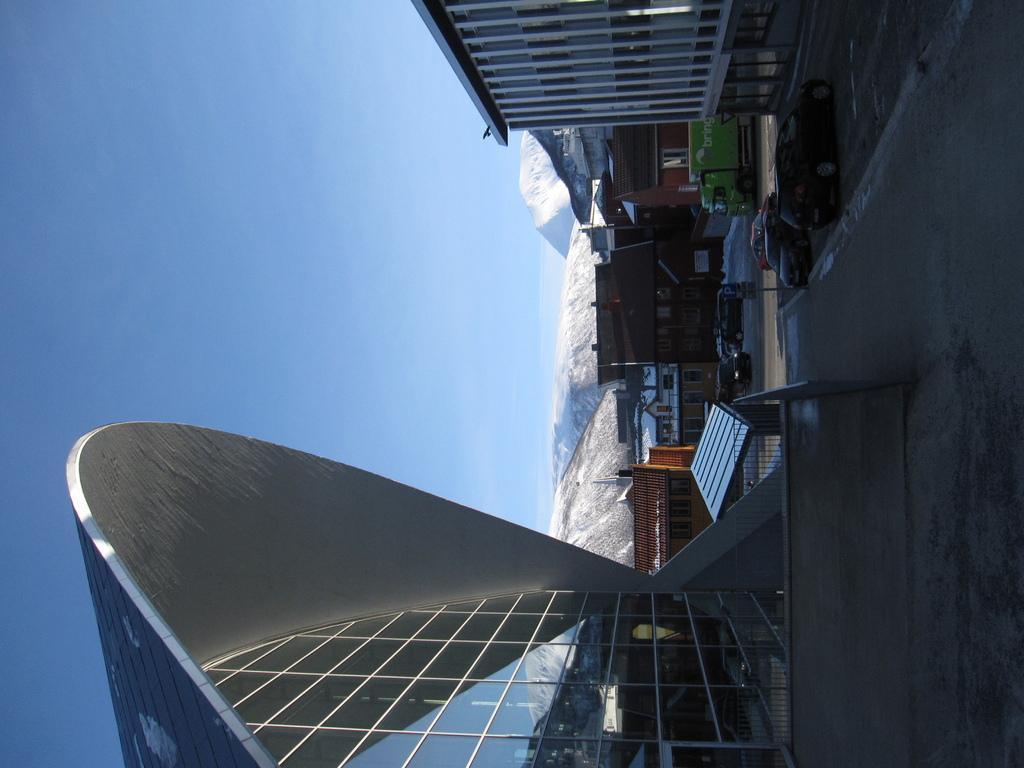Can you describe this image briefly? This image consists of buildings. On the right, we can see the cars parked on the road. In the background, there are mountains covered with the snow. At the top, there is sky. 